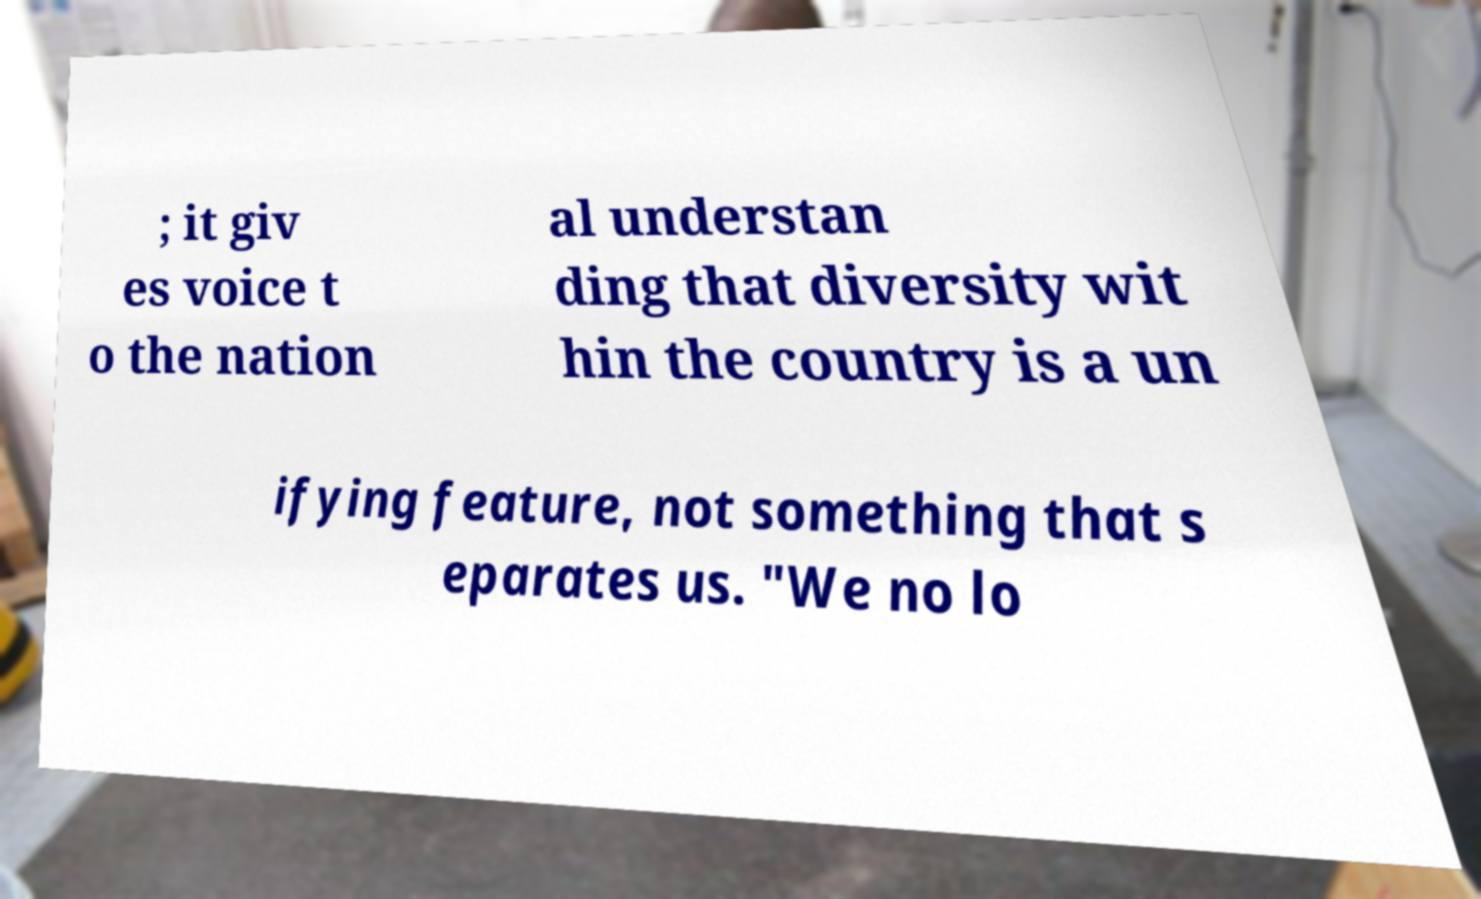Could you assist in decoding the text presented in this image and type it out clearly? ; it giv es voice t o the nation al understan ding that diversity wit hin the country is a un ifying feature, not something that s eparates us. "We no lo 